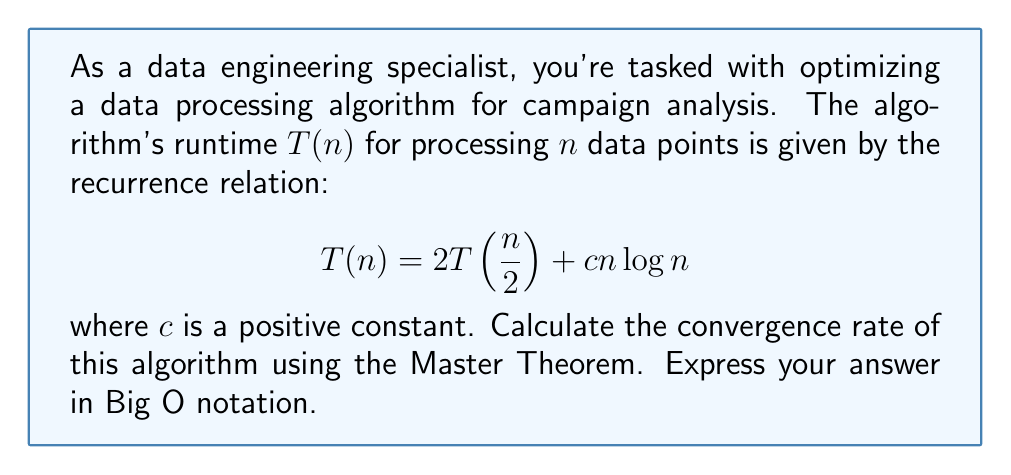Could you help me with this problem? To solve this problem, we'll use the Master Theorem, which is applicable for recurrences of the form:

$$T(n) = aT(\frac{n}{b}) + f(n)$$

where $a \geq 1$, $b > 1$, and $f(n)$ is a positive function.

In our case:
$a = 2$
$b = 2$
$f(n) = cn\log n$

Step 1: Calculate $\log_b a$
$$\log_b a = \log_2 2 = 1$$

Step 2: Compare $f(n)$ with $n^{\log_b a} = n^1 = n$

We need to determine if $f(n) = O(n^{\log_b a - \epsilon})$, $f(n) = \Theta(n^{\log_b a})$, or $f(n) = \Omega(n^{\log_b a + \epsilon})$ for some $\epsilon > 0$.

In this case, $f(n) = cn\log n$ is asymptotically larger than $n$, so we fall into the third case of the Master Theorem.

Step 3: Apply the Master Theorem

Since $f(n) = \Omega(n^{\log_b a + \epsilon})$ for $\epsilon > 0$ (we can choose $\epsilon = \log\log n$), and $af(\frac{n}{b}) \leq kf(n)$ for some constant $k < 1$ and sufficiently large $n$, we can conclude:

$$T(n) = \Theta(f(n)) = \Theta(n\log n)$$

Therefore, the convergence rate of the algorithm is $O(n\log n)$.
Answer: $O(n\log n)$ 